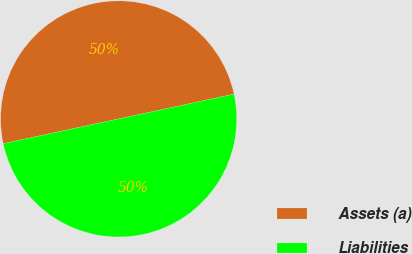<chart> <loc_0><loc_0><loc_500><loc_500><pie_chart><fcel>Assets (a)<fcel>Liabilities<nl><fcel>49.99%<fcel>50.01%<nl></chart> 